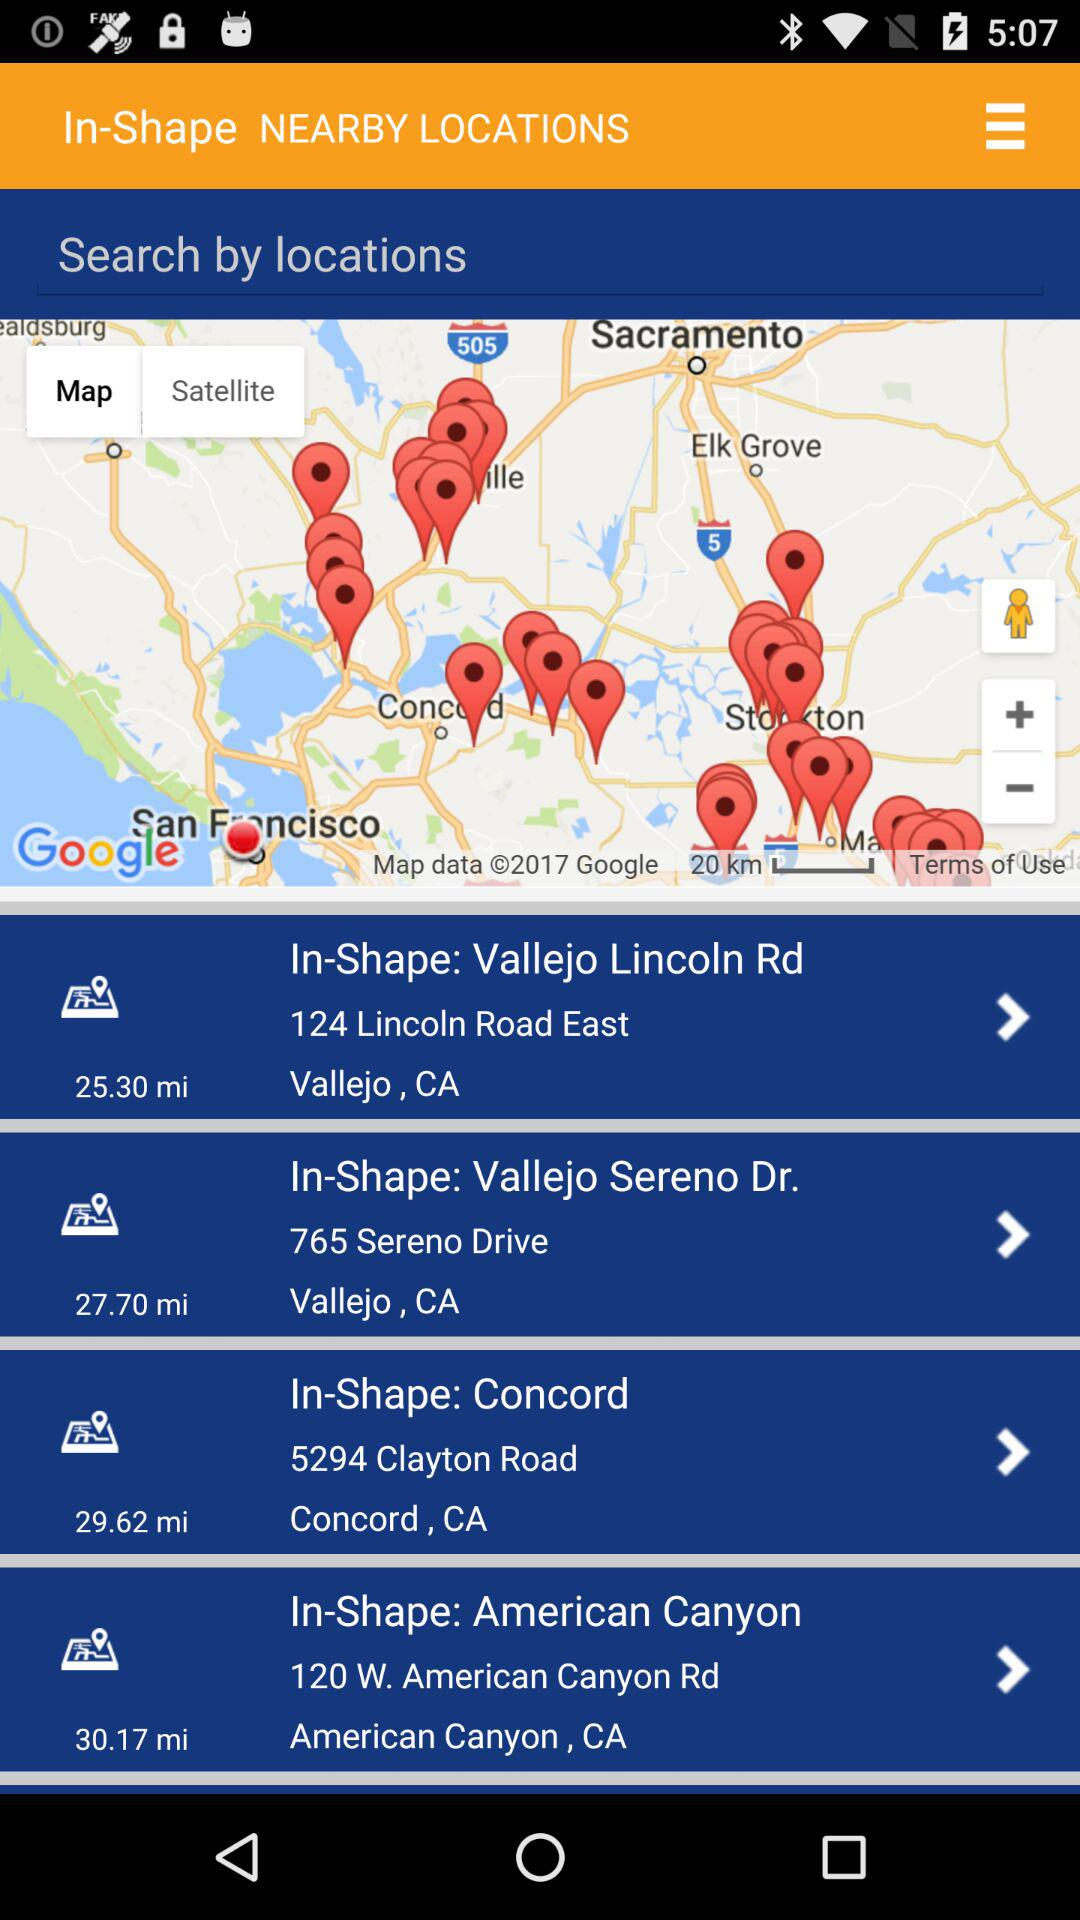What is the zip code of the In-Shape location in Vallejo on Sereno Drive?
When the provided information is insufficient, respond with <no answer>. <no answer> 